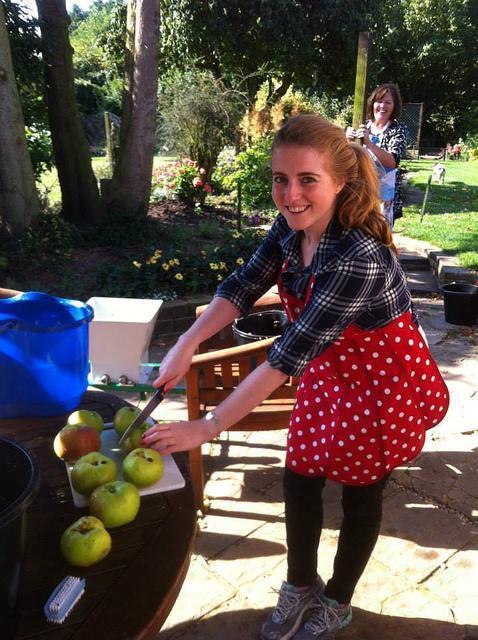How many people are there?
Give a very brief answer. 2. How many cars does the train Offer?
Give a very brief answer. 0. 